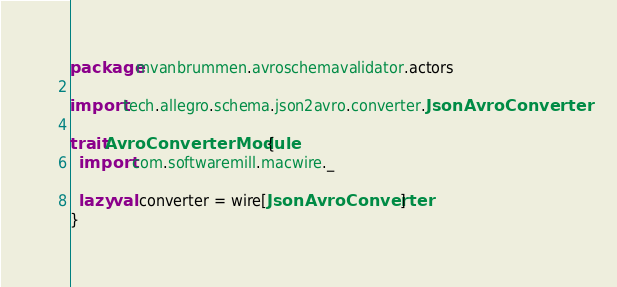Convert code to text. <code><loc_0><loc_0><loc_500><loc_500><_Scala_>package mvanbrummen.avroschemavalidator.actors

import tech.allegro.schema.json2avro.converter.JsonAvroConverter

trait AvroConverterModule {
  import com.softwaremill.macwire._

  lazy val converter = wire[JsonAvroConverter]
}
</code> 